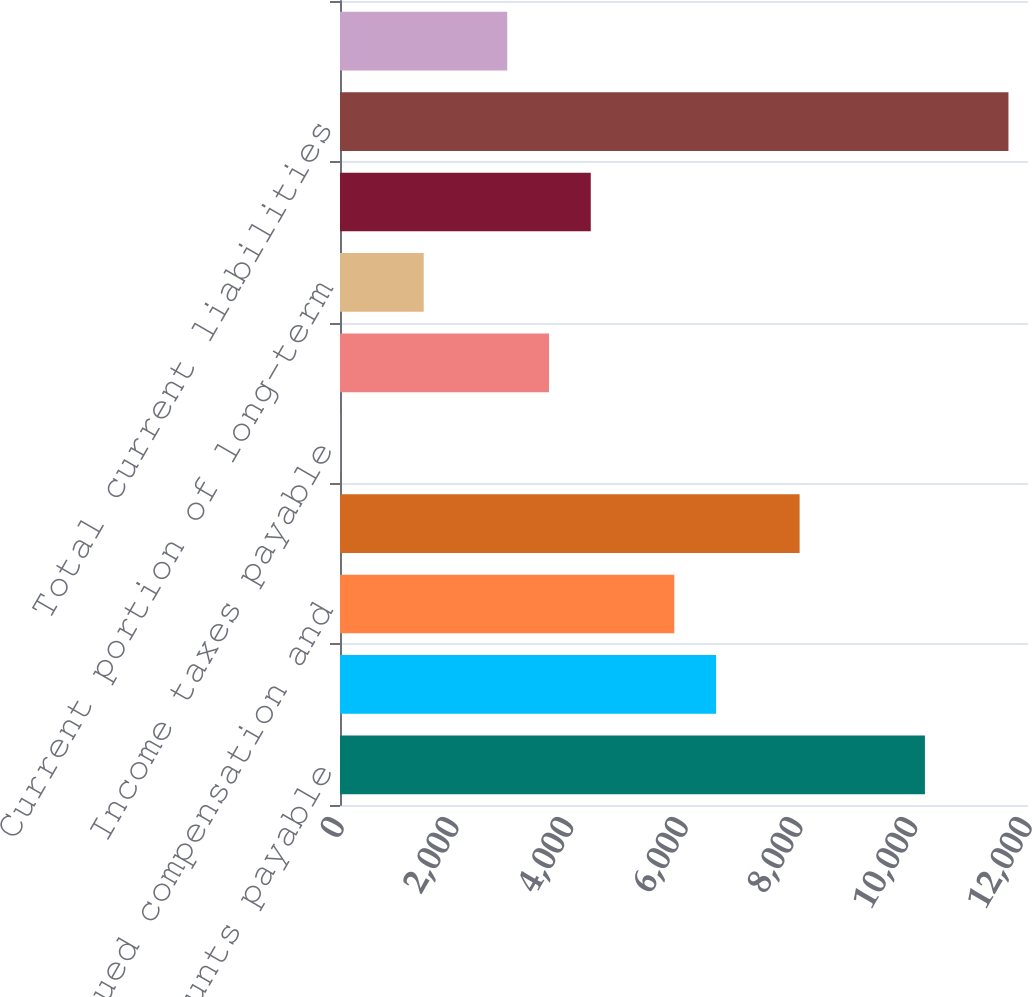<chart> <loc_0><loc_0><loc_500><loc_500><bar_chart><fcel>Accounts payable<fcel>Accounts payable to Spansion<fcel>Accrued compensation and<fcel>Accrued liabilities<fcel>Income taxes payable<fcel>Deferred income on shipments<fcel>Current portion of long-term<fcel>Other current liabilities<fcel>Total current liabilities<fcel>Deferred income taxes<nl><fcel>10202<fcel>6559.5<fcel>5831<fcel>8016.5<fcel>3<fcel>3645.5<fcel>1460<fcel>4374<fcel>11659<fcel>2917<nl></chart> 